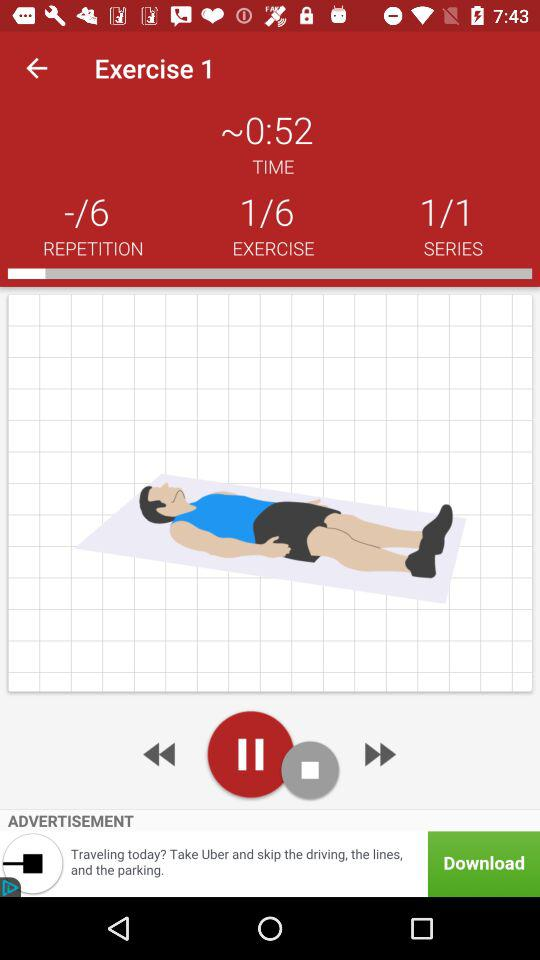What is the total number of repetitions? The total number of repetitions is 6. 